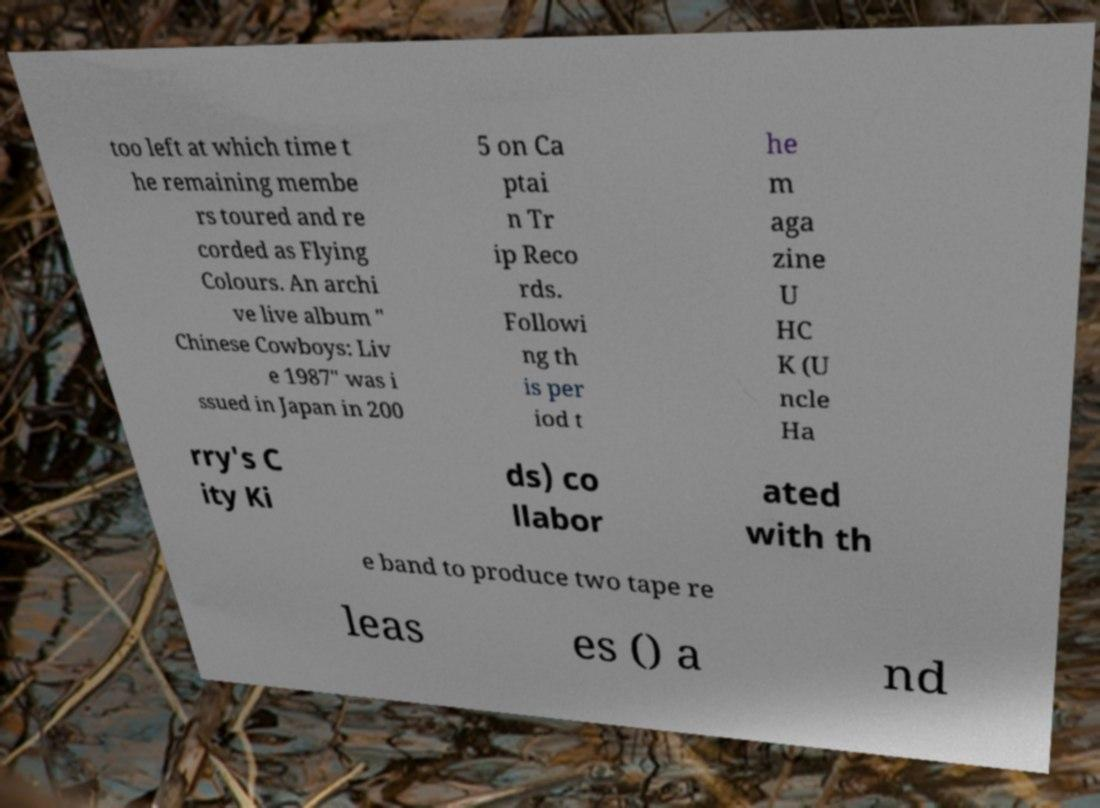Can you read and provide the text displayed in the image?This photo seems to have some interesting text. Can you extract and type it out for me? too left at which time t he remaining membe rs toured and re corded as Flying Colours. An archi ve live album " Chinese Cowboys: Liv e 1987" was i ssued in Japan in 200 5 on Ca ptai n Tr ip Reco rds. Followi ng th is per iod t he m aga zine U HC K (U ncle Ha rry's C ity Ki ds) co llabor ated with th e band to produce two tape re leas es () a nd 